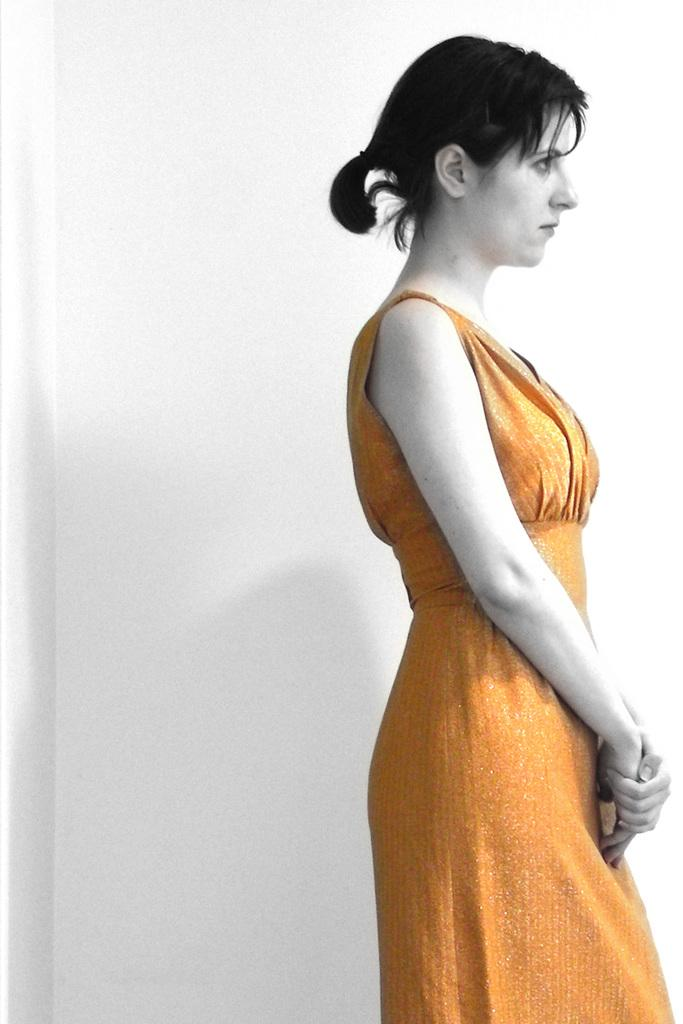Who is the main subject in the image? There is a woman in the image. What is the woman doing in the image? The woman is standing. What is the woman wearing in the image? The woman is wearing an orange dress. What direction is the woman facing in the image? The provided facts do not mention the direction the woman is facing, so we cannot determine her orientation from the image. Can you see a beetle crawling on the woman's dress in the image? There is no mention of a beetle in the image, so we cannot confirm its presence. 